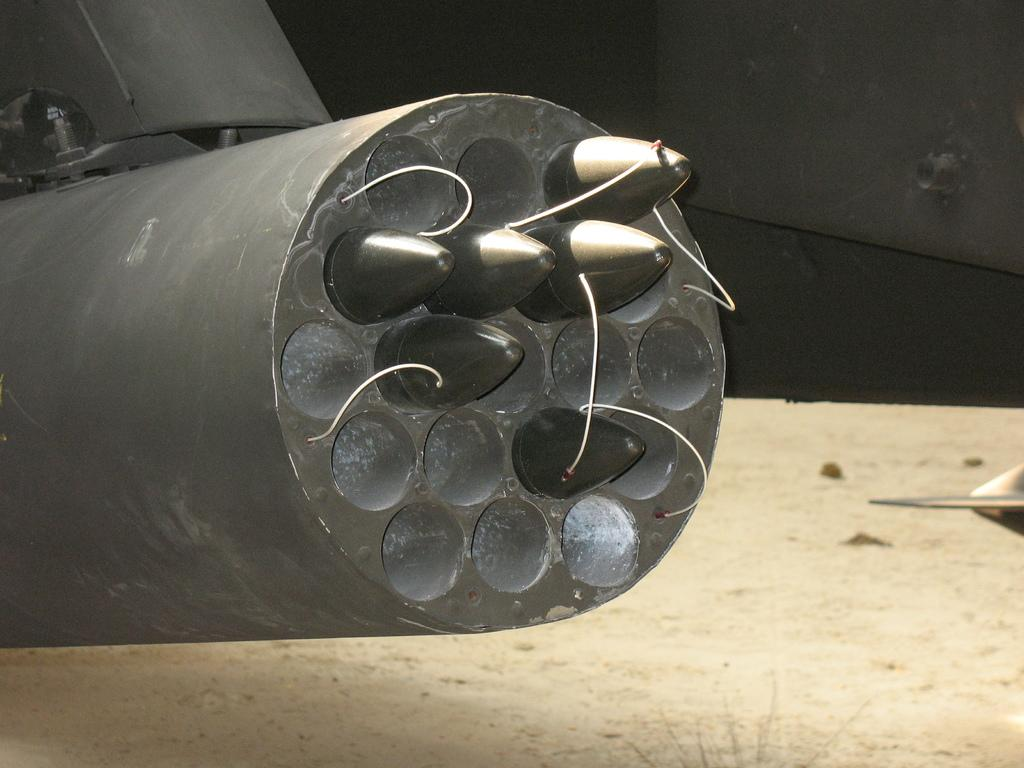What is visible at the bottom of the image? The ground is visible at the bottom of the image. What type of machine can be seen in the image? There is a machine with bullets in the image. Can you describe the unspecified objects in the image? Unfortunately, the provided facts do not specify the nature of the unspecified objects in the image. What type of cabbage is being used by the army in the image? There is no cabbage or army present in the image. What thought is being expressed by the unspecified objects in the image? The provided facts do not mention any thoughts being expressed by the unspecified objects in the image. 